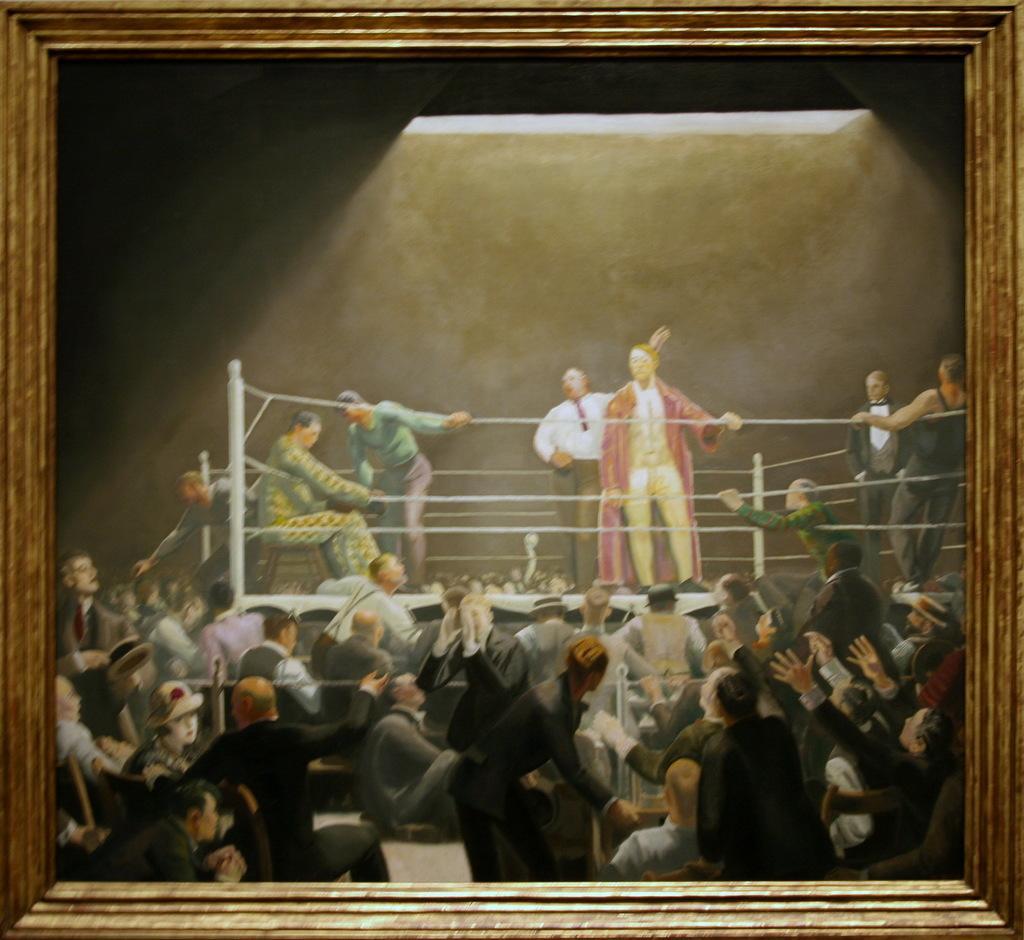Please provide a concise description of this image. This is the painting where we can see a photo frame, boxing court and so many people. At the top of the image, we can see the light. 